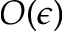<formula> <loc_0><loc_0><loc_500><loc_500>O ( \epsilon )</formula> 